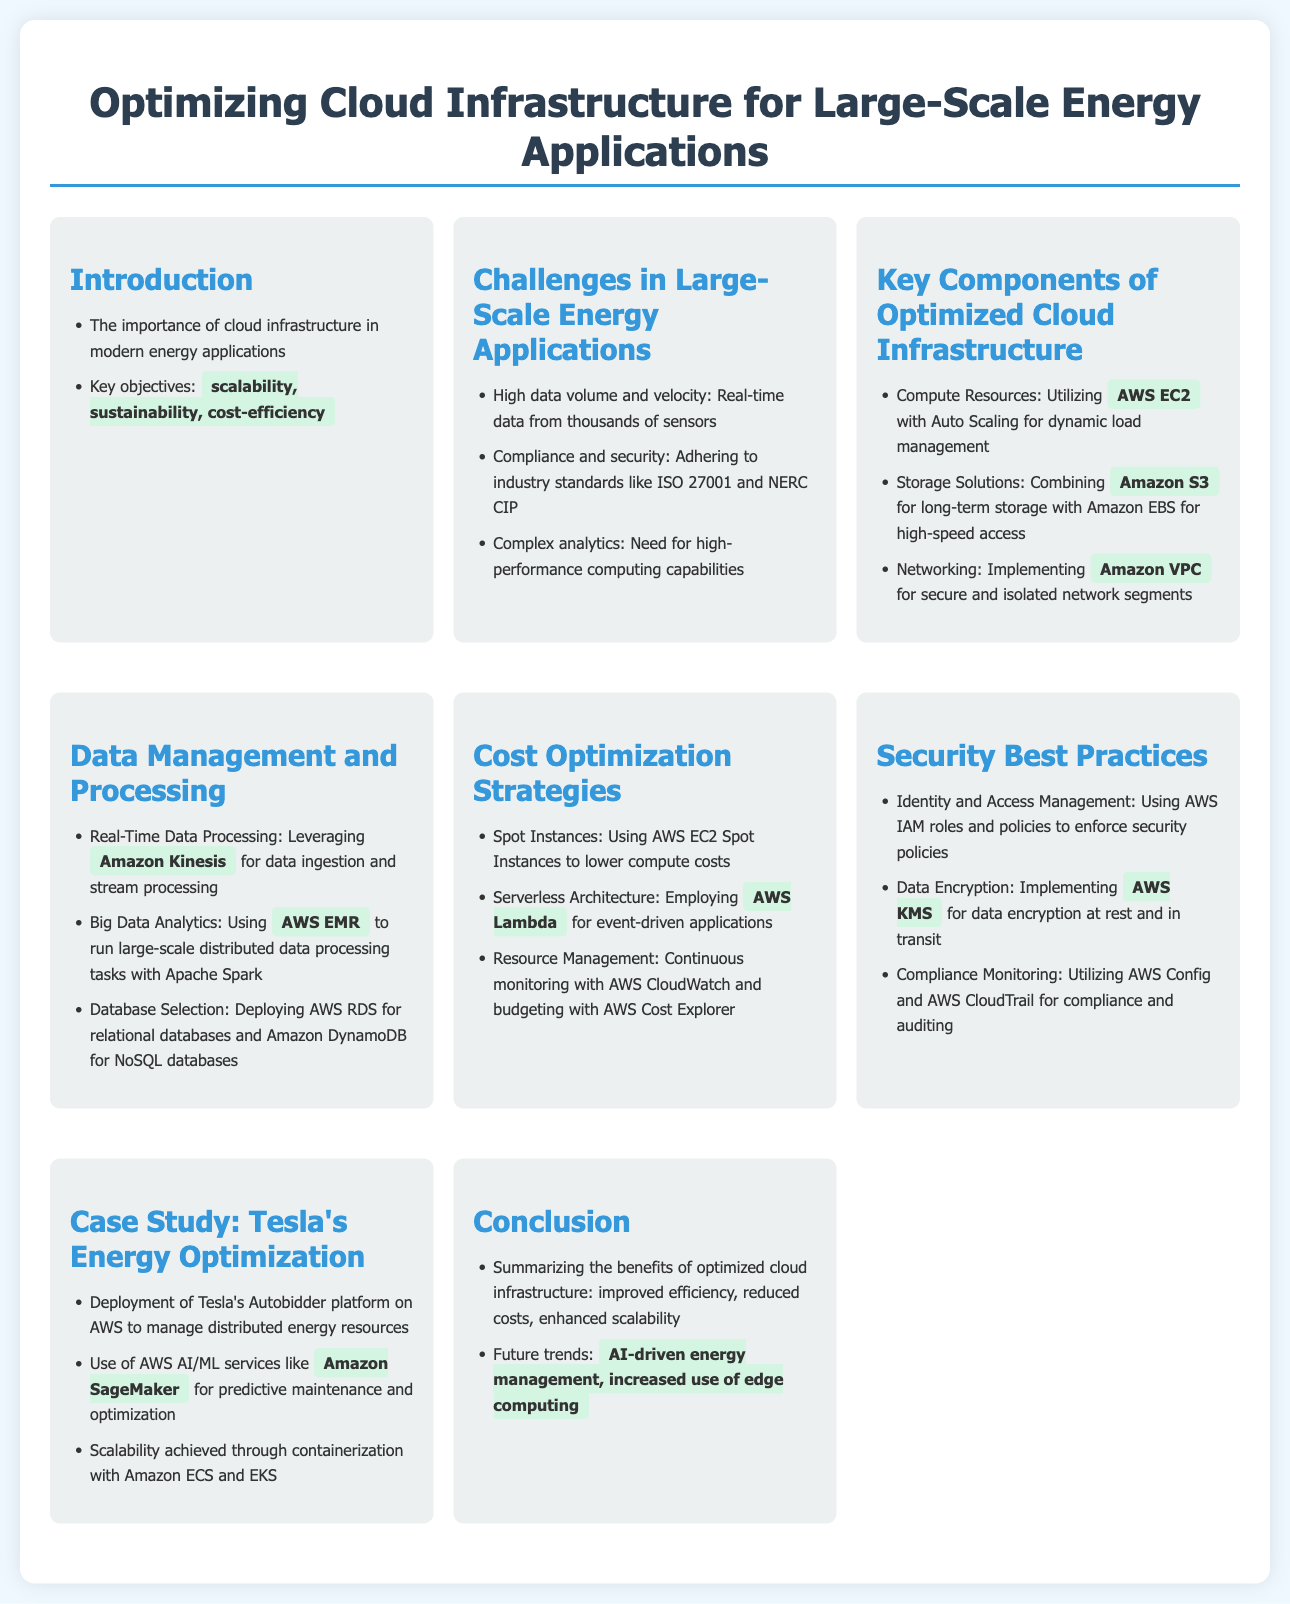What are the key objectives of cloud infrastructure optimization? The key objectives mentioned in the document are scalability, sustainability, and cost-efficiency.
Answer: scalability, sustainability, cost-efficiency What is the primary challenge regarding data in large-scale energy applications? The document states that the primary challenge is the high data volume and velocity from real-time data coming from thousands of sensors.
Answer: High data volume and velocity Which AWS service is highlighted for secure networking? The document indicates that Amazon VPC is used for secure and isolated network segments.
Answer: Amazon VPC What technique is suggested for lowering compute costs? The document recommends using AWS EC2 Spot Instances.
Answer: AWS EC2 Spot Instances Which AWS service is employed for event-driven applications? AWS Lambda is mentioned in the document as the service for event-driven applications.
Answer: AWS Lambda Which technology is mentioned for predictive maintenance in Tesla's case study? The document highlights the use of Amazon SageMaker for predictive maintenance.
Answer: Amazon SageMaker What are the benefits of optimized cloud infrastructure listed in the conclusion? The benefits listed include improved efficiency, reduced costs, and enhanced scalability.
Answer: improved efficiency, reduced costs, enhanced scalability What does the document propose as a future trend in energy management? The document notes that AI-driven energy management and increased use of edge computing are future trends.
Answer: AI-driven energy management, increased use of edge computing 